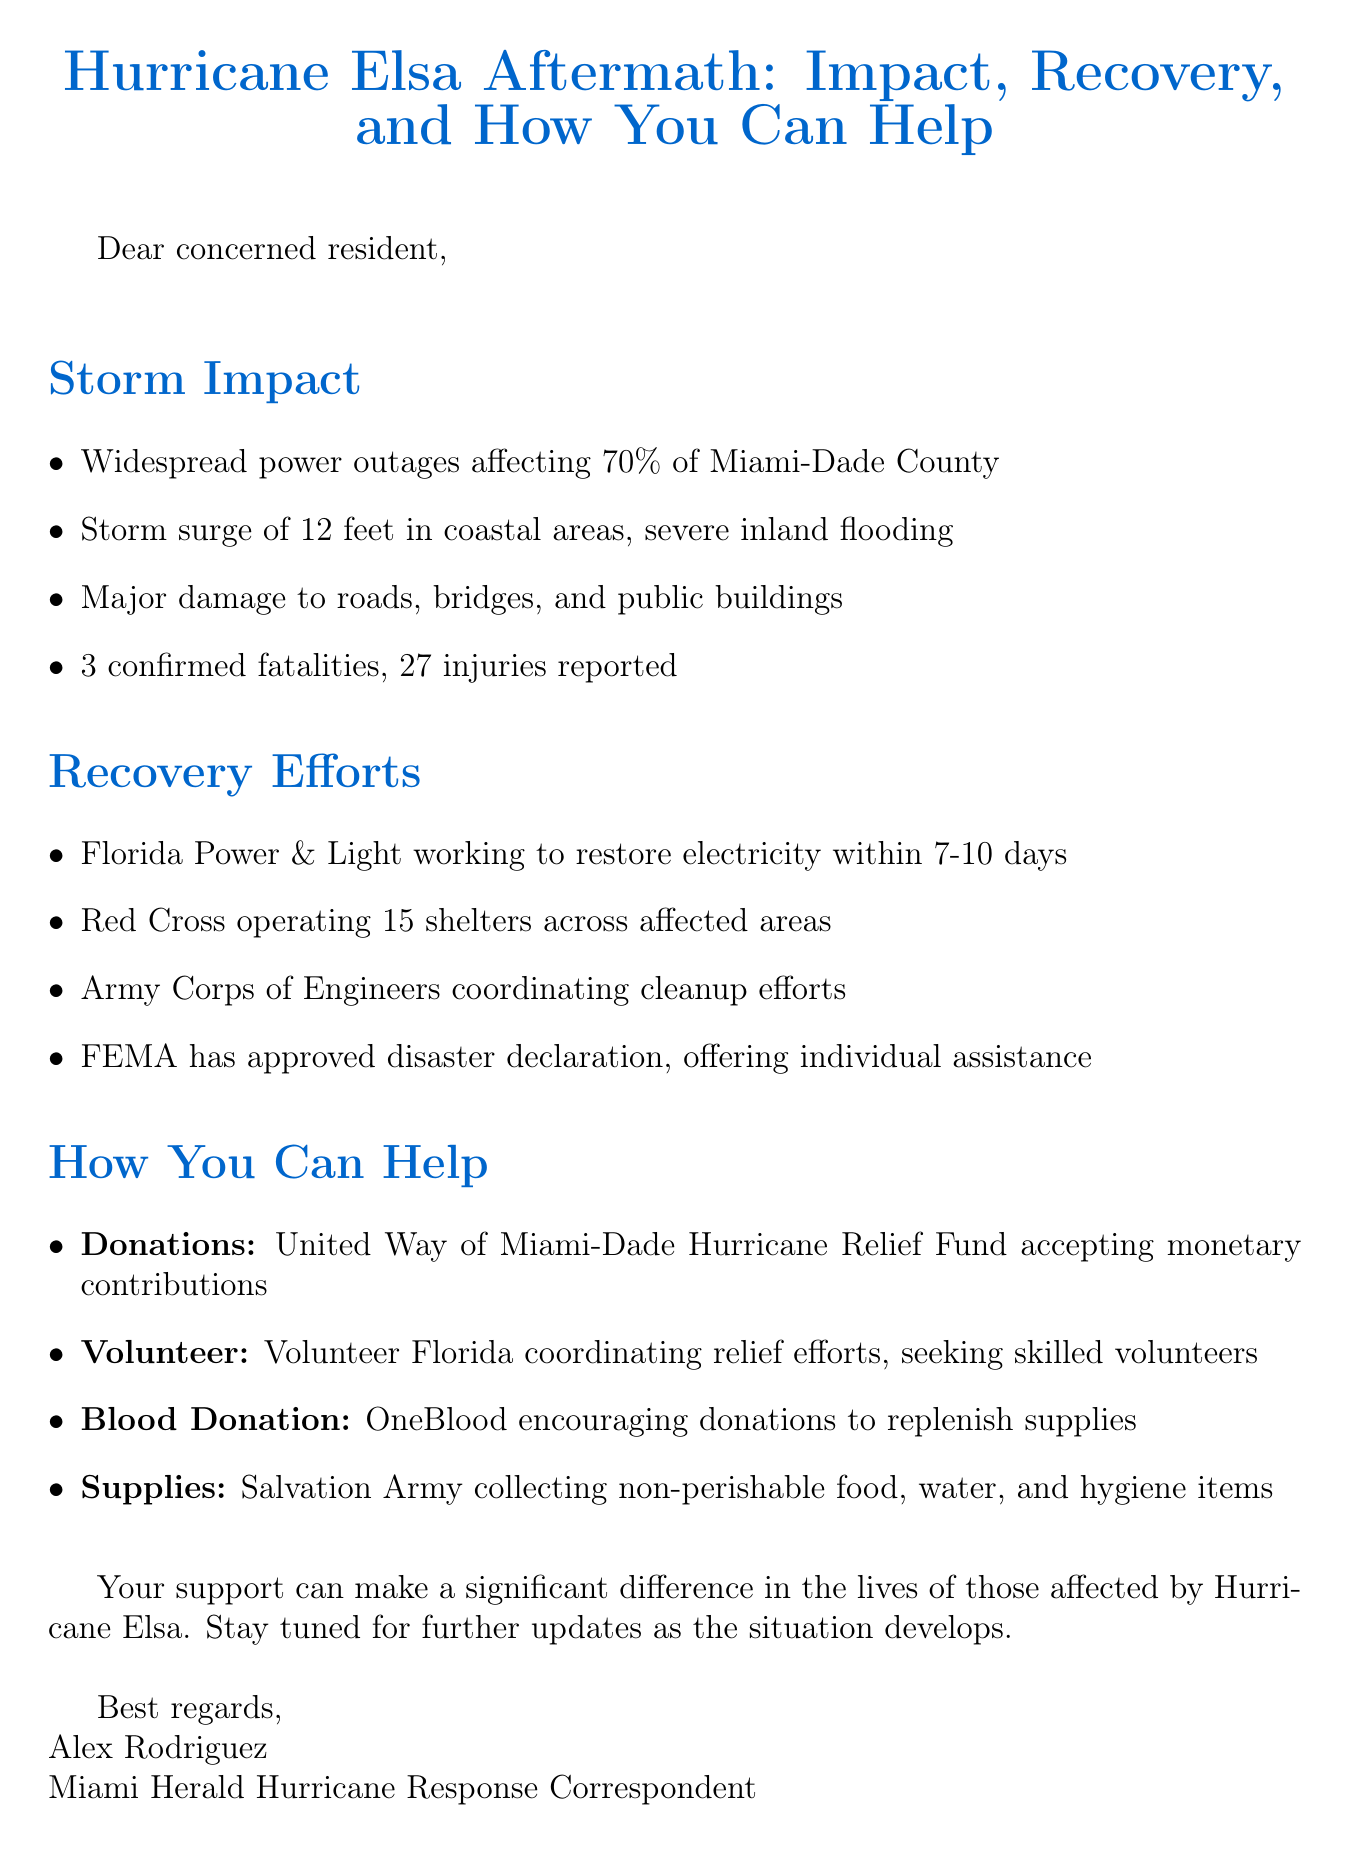What is the title of the email? The title of the email is indicated at the top of the document and summarizes the content regarding Hurricane Elsa's aftermath.
Answer: Hurricane Elsa Aftermath: Impact, Recovery, and How You Can Help What percentage of Miami-Dade County is affected by power outages? This percentage is mentioned in the section about storm impact, highlighting the scale of the power outages.
Answer: 70% How many confirmed fatalities were there due to the hurricane? The number of fatalities is specifically listed in the storm impact section of the email.
Answer: 3 What organization is operating 15 shelters? The specific organization providing shelter in affected areas is named in the recovery efforts section of the document.
Answer: Red Cross In how many days is Florida Power & Light aiming to restore electricity? This timeframe for power restoration is provided in the section on recovery efforts.
Answer: 7-10 days What is one resource for making monetary donations? This resource is listed under the section for how people can help, specifically regarding financial assistance.
Answer: United Way of Miami-Dade Hurricane Relief Fund What type of items is the Salvation Army collecting? The specific category of items sought by the Salvation Army is outlined in the resources to help section.
Answer: Non-perishable food, water, and hygiene items Which organization is coordinating relief efforts and seeking skilled volunteers? This organization is mentioned in the section discussing volunteer opportunities to aid the affected communities.
Answer: Volunteer Florida What is the main purpose of this email? The purpose is indicated by the overarching themes of storm impact, recovery efforts, and calls to action for support.
Answer: To inform and mobilize aid for hurricane-affected communities 